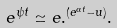Convert formula to latex. <formula><loc_0><loc_0><loc_500><loc_500>e ^ { \psi t } \simeq e . ^ { ( e ^ { \alpha t } - u ) } .</formula> 